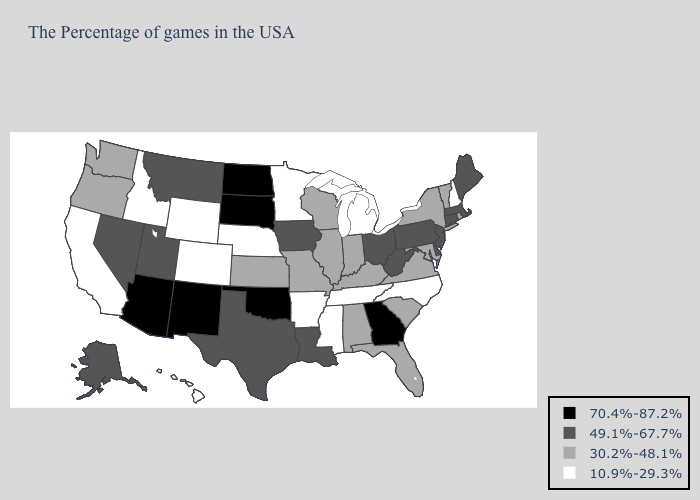How many symbols are there in the legend?
Answer briefly. 4. Name the states that have a value in the range 49.1%-67.7%?
Give a very brief answer. Maine, Massachusetts, Connecticut, New Jersey, Delaware, Pennsylvania, West Virginia, Ohio, Louisiana, Iowa, Texas, Utah, Montana, Nevada, Alaska. What is the value of Louisiana?
Be succinct. 49.1%-67.7%. What is the lowest value in states that border Oklahoma?
Give a very brief answer. 10.9%-29.3%. Among the states that border Utah , does New Mexico have the lowest value?
Write a very short answer. No. What is the value of Nebraska?
Give a very brief answer. 10.9%-29.3%. Does Arizona have a lower value than Alabama?
Quick response, please. No. What is the value of Florida?
Write a very short answer. 30.2%-48.1%. Among the states that border Maryland , which have the lowest value?
Give a very brief answer. Virginia. Does Oklahoma have the highest value in the USA?
Give a very brief answer. Yes. Name the states that have a value in the range 10.9%-29.3%?
Write a very short answer. New Hampshire, North Carolina, Michigan, Tennessee, Mississippi, Arkansas, Minnesota, Nebraska, Wyoming, Colorado, Idaho, California, Hawaii. Name the states that have a value in the range 30.2%-48.1%?
Keep it brief. Rhode Island, Vermont, New York, Maryland, Virginia, South Carolina, Florida, Kentucky, Indiana, Alabama, Wisconsin, Illinois, Missouri, Kansas, Washington, Oregon. Among the states that border Ohio , does Michigan have the lowest value?
Keep it brief. Yes. Which states have the lowest value in the USA?
Write a very short answer. New Hampshire, North Carolina, Michigan, Tennessee, Mississippi, Arkansas, Minnesota, Nebraska, Wyoming, Colorado, Idaho, California, Hawaii. What is the value of Tennessee?
Answer briefly. 10.9%-29.3%. 